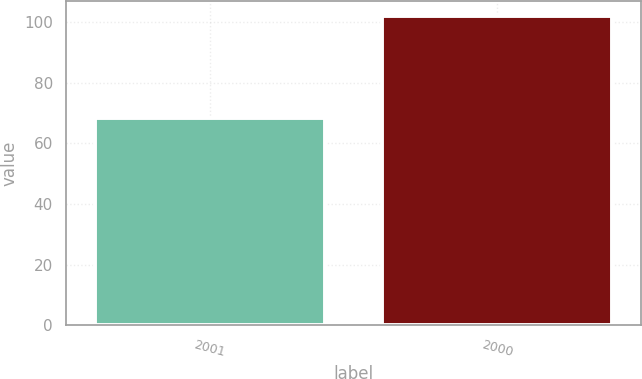Convert chart to OTSL. <chart><loc_0><loc_0><loc_500><loc_500><bar_chart><fcel>2001<fcel>2000<nl><fcel>68.3<fcel>101.89<nl></chart> 